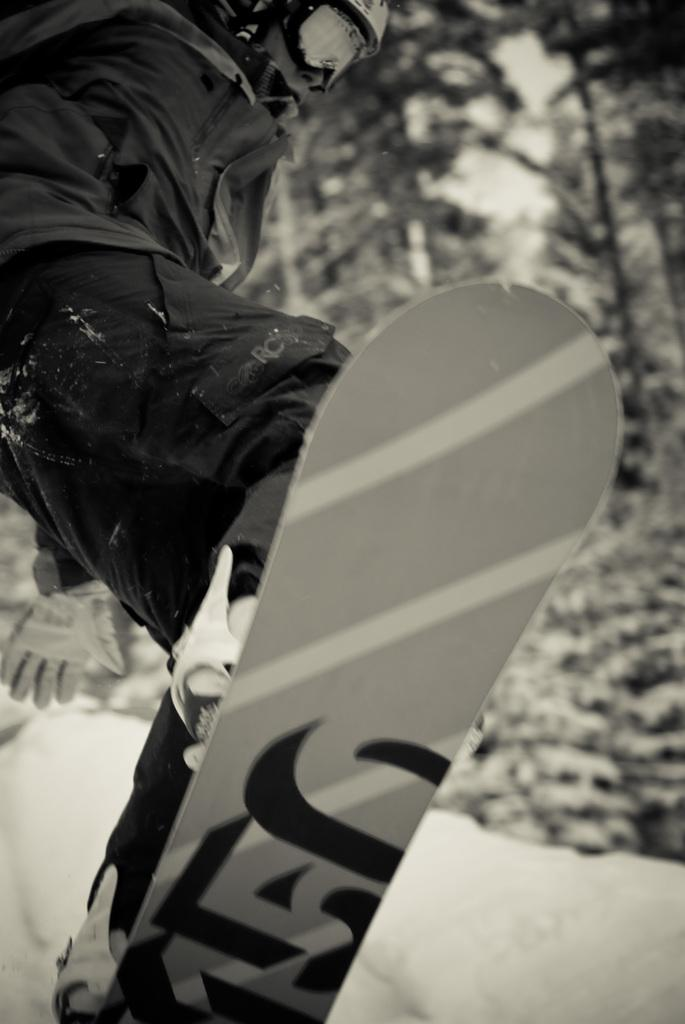What is the main subject of the image? There is a person in the image. What activity is the person engaged in? The person is skating. What can be seen in the background of the image? There are trees visible in the image. How many rings does the beggar have in the image? There is no beggar present in the image, and therefore no rings can be associated with them. 